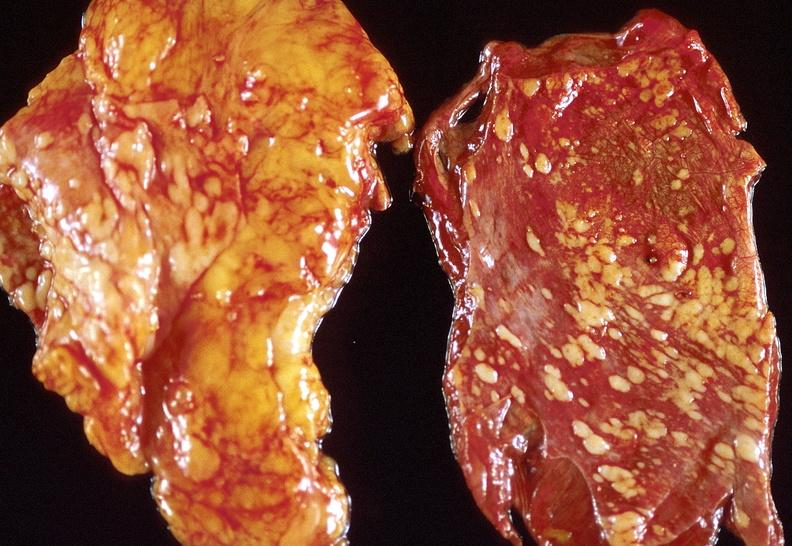where is this?
Answer the question using a single word or phrase. Lung 